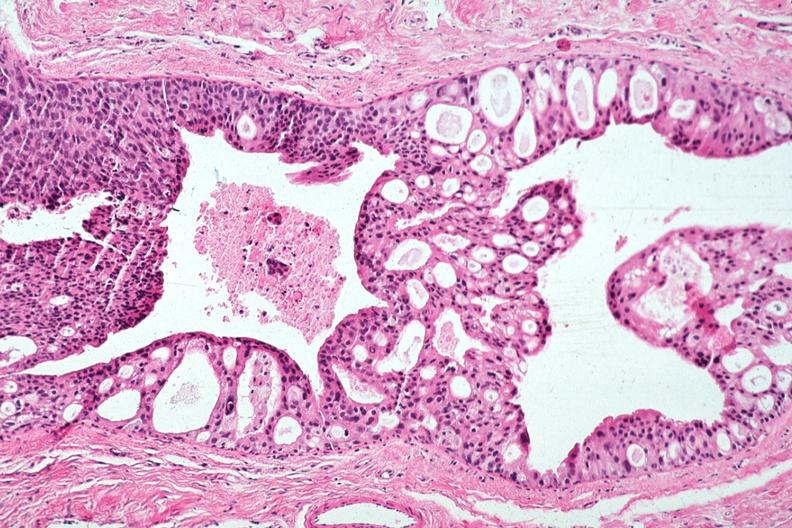does polycystic disease show excellent cribriform pattern all tumor in duct?
Answer the question using a single word or phrase. No 